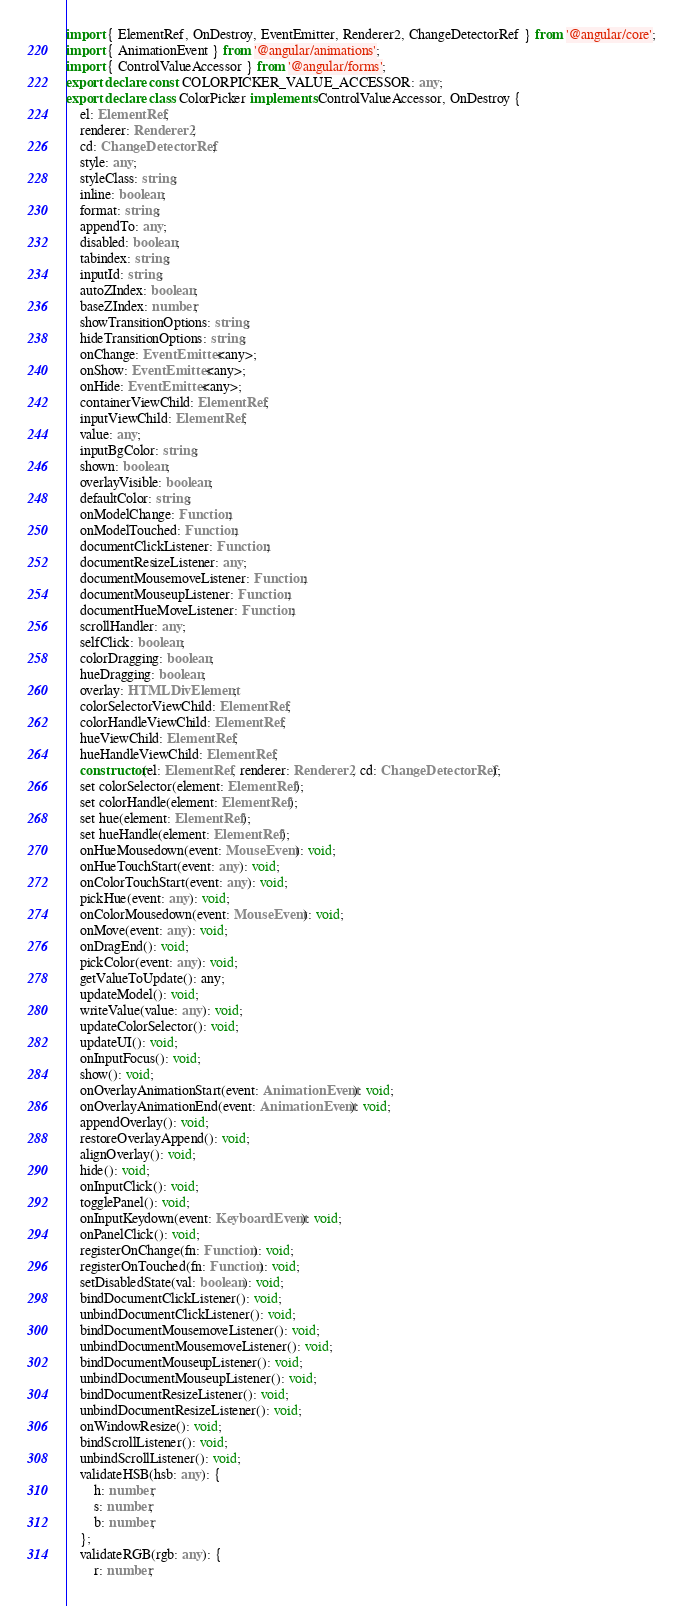Convert code to text. <code><loc_0><loc_0><loc_500><loc_500><_TypeScript_>import { ElementRef, OnDestroy, EventEmitter, Renderer2, ChangeDetectorRef } from '@angular/core';
import { AnimationEvent } from '@angular/animations';
import { ControlValueAccessor } from '@angular/forms';
export declare const COLORPICKER_VALUE_ACCESSOR: any;
export declare class ColorPicker implements ControlValueAccessor, OnDestroy {
    el: ElementRef;
    renderer: Renderer2;
    cd: ChangeDetectorRef;
    style: any;
    styleClass: string;
    inline: boolean;
    format: string;
    appendTo: any;
    disabled: boolean;
    tabindex: string;
    inputId: string;
    autoZIndex: boolean;
    baseZIndex: number;
    showTransitionOptions: string;
    hideTransitionOptions: string;
    onChange: EventEmitter<any>;
    onShow: EventEmitter<any>;
    onHide: EventEmitter<any>;
    containerViewChild: ElementRef;
    inputViewChild: ElementRef;
    value: any;
    inputBgColor: string;
    shown: boolean;
    overlayVisible: boolean;
    defaultColor: string;
    onModelChange: Function;
    onModelTouched: Function;
    documentClickListener: Function;
    documentResizeListener: any;
    documentMousemoveListener: Function;
    documentMouseupListener: Function;
    documentHueMoveListener: Function;
    scrollHandler: any;
    selfClick: boolean;
    colorDragging: boolean;
    hueDragging: boolean;
    overlay: HTMLDivElement;
    colorSelectorViewChild: ElementRef;
    colorHandleViewChild: ElementRef;
    hueViewChild: ElementRef;
    hueHandleViewChild: ElementRef;
    constructor(el: ElementRef, renderer: Renderer2, cd: ChangeDetectorRef);
    set colorSelector(element: ElementRef);
    set colorHandle(element: ElementRef);
    set hue(element: ElementRef);
    set hueHandle(element: ElementRef);
    onHueMousedown(event: MouseEvent): void;
    onHueTouchStart(event: any): void;
    onColorTouchStart(event: any): void;
    pickHue(event: any): void;
    onColorMousedown(event: MouseEvent): void;
    onMove(event: any): void;
    onDragEnd(): void;
    pickColor(event: any): void;
    getValueToUpdate(): any;
    updateModel(): void;
    writeValue(value: any): void;
    updateColorSelector(): void;
    updateUI(): void;
    onInputFocus(): void;
    show(): void;
    onOverlayAnimationStart(event: AnimationEvent): void;
    onOverlayAnimationEnd(event: AnimationEvent): void;
    appendOverlay(): void;
    restoreOverlayAppend(): void;
    alignOverlay(): void;
    hide(): void;
    onInputClick(): void;
    togglePanel(): void;
    onInputKeydown(event: KeyboardEvent): void;
    onPanelClick(): void;
    registerOnChange(fn: Function): void;
    registerOnTouched(fn: Function): void;
    setDisabledState(val: boolean): void;
    bindDocumentClickListener(): void;
    unbindDocumentClickListener(): void;
    bindDocumentMousemoveListener(): void;
    unbindDocumentMousemoveListener(): void;
    bindDocumentMouseupListener(): void;
    unbindDocumentMouseupListener(): void;
    bindDocumentResizeListener(): void;
    unbindDocumentResizeListener(): void;
    onWindowResize(): void;
    bindScrollListener(): void;
    unbindScrollListener(): void;
    validateHSB(hsb: any): {
        h: number;
        s: number;
        b: number;
    };
    validateRGB(rgb: any): {
        r: number;</code> 